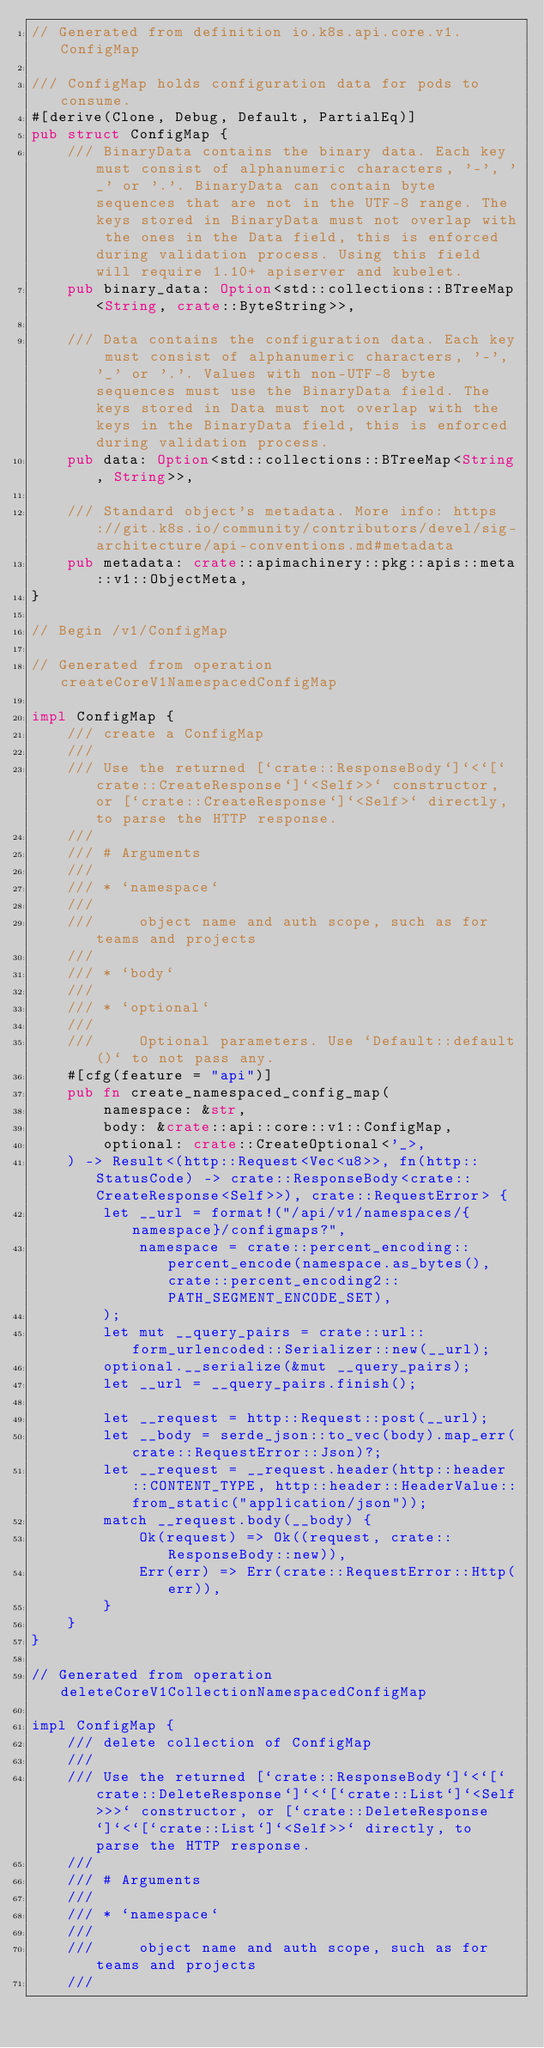Convert code to text. <code><loc_0><loc_0><loc_500><loc_500><_Rust_>// Generated from definition io.k8s.api.core.v1.ConfigMap

/// ConfigMap holds configuration data for pods to consume.
#[derive(Clone, Debug, Default, PartialEq)]
pub struct ConfigMap {
    /// BinaryData contains the binary data. Each key must consist of alphanumeric characters, '-', '_' or '.'. BinaryData can contain byte sequences that are not in the UTF-8 range. The keys stored in BinaryData must not overlap with the ones in the Data field, this is enforced during validation process. Using this field will require 1.10+ apiserver and kubelet.
    pub binary_data: Option<std::collections::BTreeMap<String, crate::ByteString>>,

    /// Data contains the configuration data. Each key must consist of alphanumeric characters, '-', '_' or '.'. Values with non-UTF-8 byte sequences must use the BinaryData field. The keys stored in Data must not overlap with the keys in the BinaryData field, this is enforced during validation process.
    pub data: Option<std::collections::BTreeMap<String, String>>,

    /// Standard object's metadata. More info: https://git.k8s.io/community/contributors/devel/sig-architecture/api-conventions.md#metadata
    pub metadata: crate::apimachinery::pkg::apis::meta::v1::ObjectMeta,
}

// Begin /v1/ConfigMap

// Generated from operation createCoreV1NamespacedConfigMap

impl ConfigMap {
    /// create a ConfigMap
    ///
    /// Use the returned [`crate::ResponseBody`]`<`[`crate::CreateResponse`]`<Self>>` constructor, or [`crate::CreateResponse`]`<Self>` directly, to parse the HTTP response.
    ///
    /// # Arguments
    ///
    /// * `namespace`
    ///
    ///     object name and auth scope, such as for teams and projects
    ///
    /// * `body`
    ///
    /// * `optional`
    ///
    ///     Optional parameters. Use `Default::default()` to not pass any.
    #[cfg(feature = "api")]
    pub fn create_namespaced_config_map(
        namespace: &str,
        body: &crate::api::core::v1::ConfigMap,
        optional: crate::CreateOptional<'_>,
    ) -> Result<(http::Request<Vec<u8>>, fn(http::StatusCode) -> crate::ResponseBody<crate::CreateResponse<Self>>), crate::RequestError> {
        let __url = format!("/api/v1/namespaces/{namespace}/configmaps?",
            namespace = crate::percent_encoding::percent_encode(namespace.as_bytes(), crate::percent_encoding2::PATH_SEGMENT_ENCODE_SET),
        );
        let mut __query_pairs = crate::url::form_urlencoded::Serializer::new(__url);
        optional.__serialize(&mut __query_pairs);
        let __url = __query_pairs.finish();

        let __request = http::Request::post(__url);
        let __body = serde_json::to_vec(body).map_err(crate::RequestError::Json)?;
        let __request = __request.header(http::header::CONTENT_TYPE, http::header::HeaderValue::from_static("application/json"));
        match __request.body(__body) {
            Ok(request) => Ok((request, crate::ResponseBody::new)),
            Err(err) => Err(crate::RequestError::Http(err)),
        }
    }
}

// Generated from operation deleteCoreV1CollectionNamespacedConfigMap

impl ConfigMap {
    /// delete collection of ConfigMap
    ///
    /// Use the returned [`crate::ResponseBody`]`<`[`crate::DeleteResponse`]`<`[`crate::List`]`<Self>>>` constructor, or [`crate::DeleteResponse`]`<`[`crate::List`]`<Self>>` directly, to parse the HTTP response.
    ///
    /// # Arguments
    ///
    /// * `namespace`
    ///
    ///     object name and auth scope, such as for teams and projects
    ///</code> 